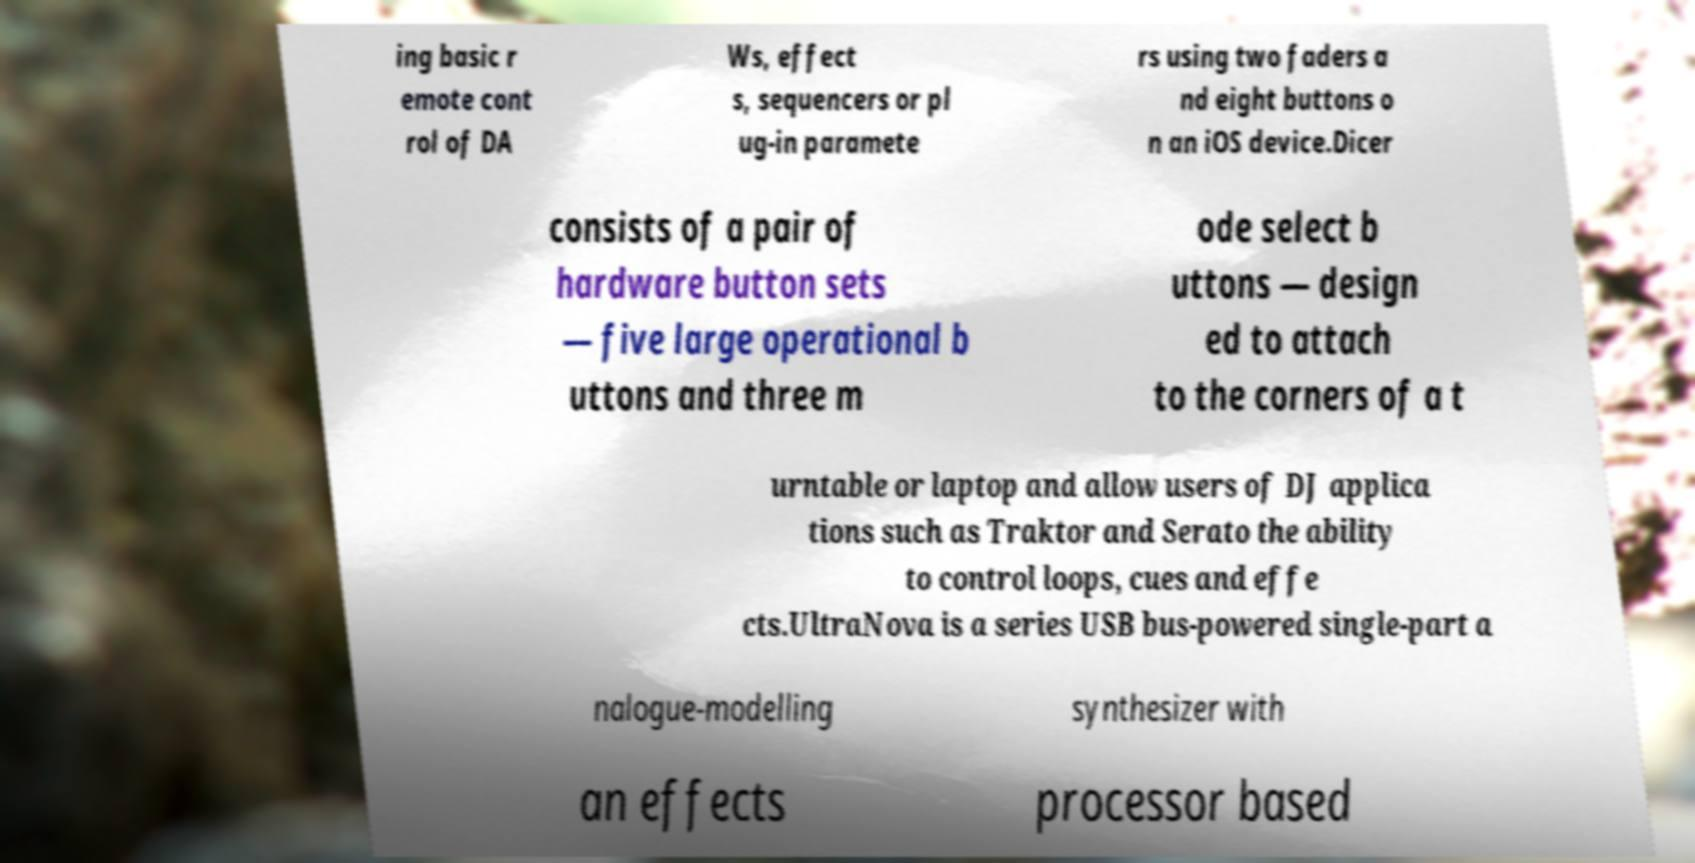I need the written content from this picture converted into text. Can you do that? ing basic r emote cont rol of DA Ws, effect s, sequencers or pl ug-in paramete rs using two faders a nd eight buttons o n an iOS device.Dicer consists of a pair of hardware button sets — five large operational b uttons and three m ode select b uttons — design ed to attach to the corners of a t urntable or laptop and allow users of DJ applica tions such as Traktor and Serato the ability to control loops, cues and effe cts.UltraNova is a series USB bus-powered single-part a nalogue-modelling synthesizer with an effects processor based 